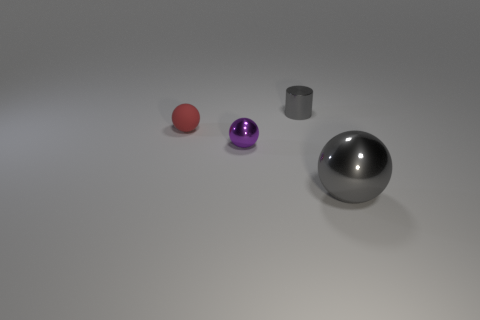Subtract all tiny red rubber spheres. How many spheres are left? 2 Add 3 gray metallic objects. How many objects exist? 7 Subtract all red balls. How many balls are left? 2 Subtract 1 spheres. How many spheres are left? 2 Add 1 tiny gray things. How many tiny gray things are left? 2 Add 3 large red matte things. How many large red matte things exist? 3 Subtract 0 yellow cylinders. How many objects are left? 4 Subtract all cylinders. How many objects are left? 3 Subtract all cyan cylinders. Subtract all blue cubes. How many cylinders are left? 1 Subtract all small metal balls. Subtract all big gray things. How many objects are left? 2 